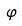Convert formula to latex. <formula><loc_0><loc_0><loc_500><loc_500>\varphi</formula> 